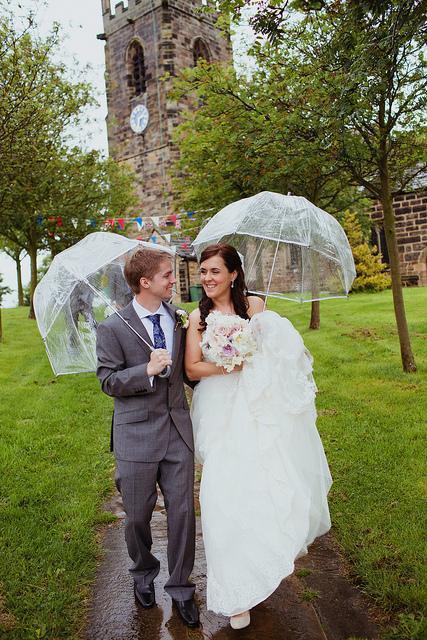How many umbrellas is the man holding?
Give a very brief answer. 1. How many umbrellas are there?
Give a very brief answer. 1. How many people are there?
Give a very brief answer. 2. 